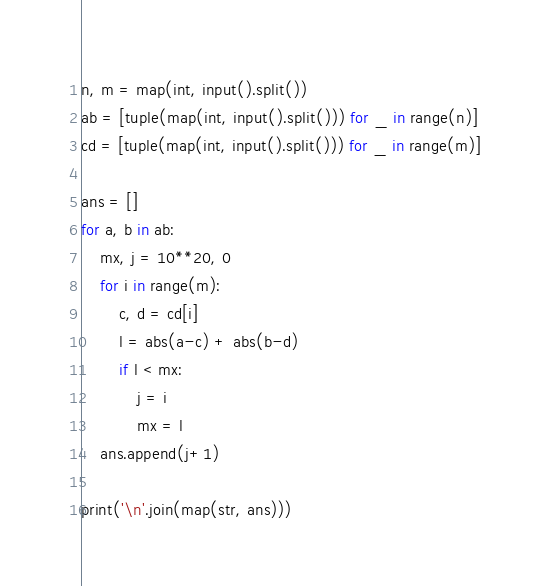Convert code to text. <code><loc_0><loc_0><loc_500><loc_500><_Python_>n, m = map(int, input().split())
ab = [tuple(map(int, input().split())) for _ in range(n)]
cd = [tuple(map(int, input().split())) for _ in range(m)]

ans = []
for a, b in ab:
    mx, j = 10**20, 0
    for i in range(m):
        c, d = cd[i]
        l = abs(a-c) + abs(b-d)
        if l < mx: 
            j = i
            mx = l
    ans.append(j+1)

print('\n'.join(map(str, ans)))</code> 